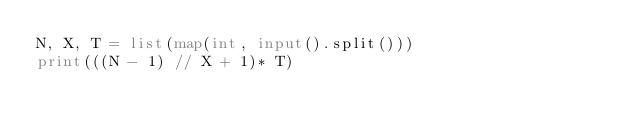<code> <loc_0><loc_0><loc_500><loc_500><_Python_>N, X, T = list(map(int, input().split()))
print(((N - 1) // X + 1)* T)</code> 